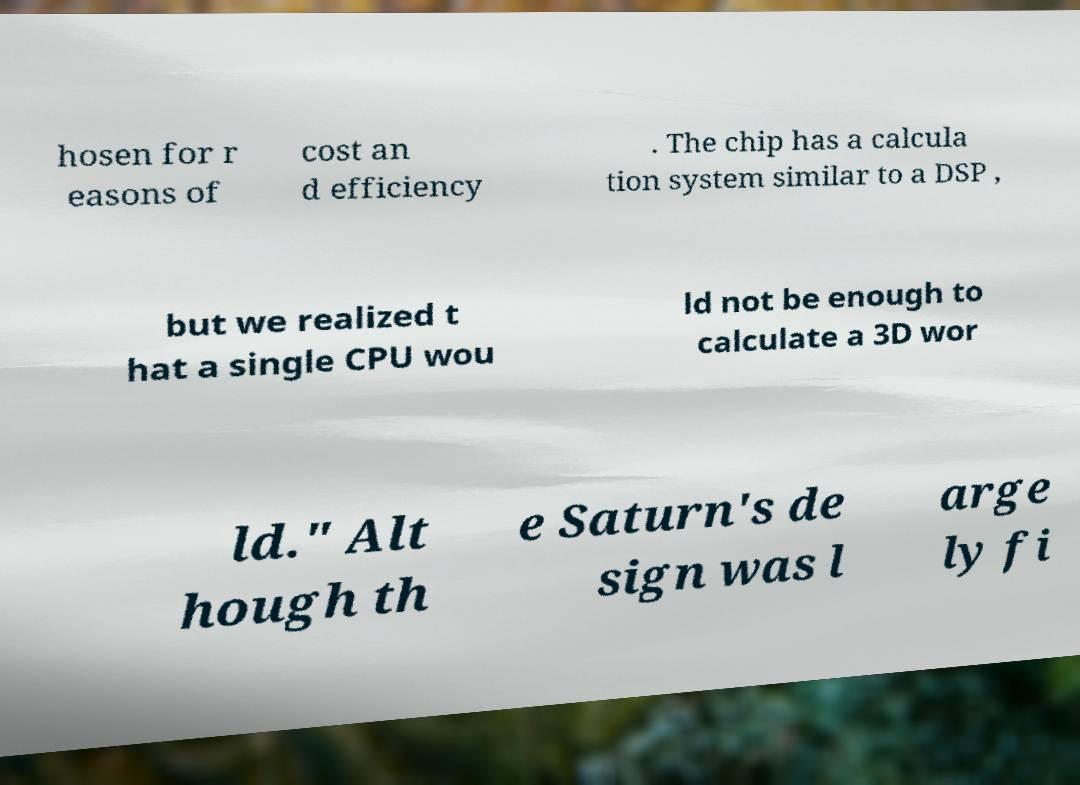Could you assist in decoding the text presented in this image and type it out clearly? hosen for r easons of cost an d efficiency . The chip has a calcula tion system similar to a DSP , but we realized t hat a single CPU wou ld not be enough to calculate a 3D wor ld." Alt hough th e Saturn's de sign was l arge ly fi 